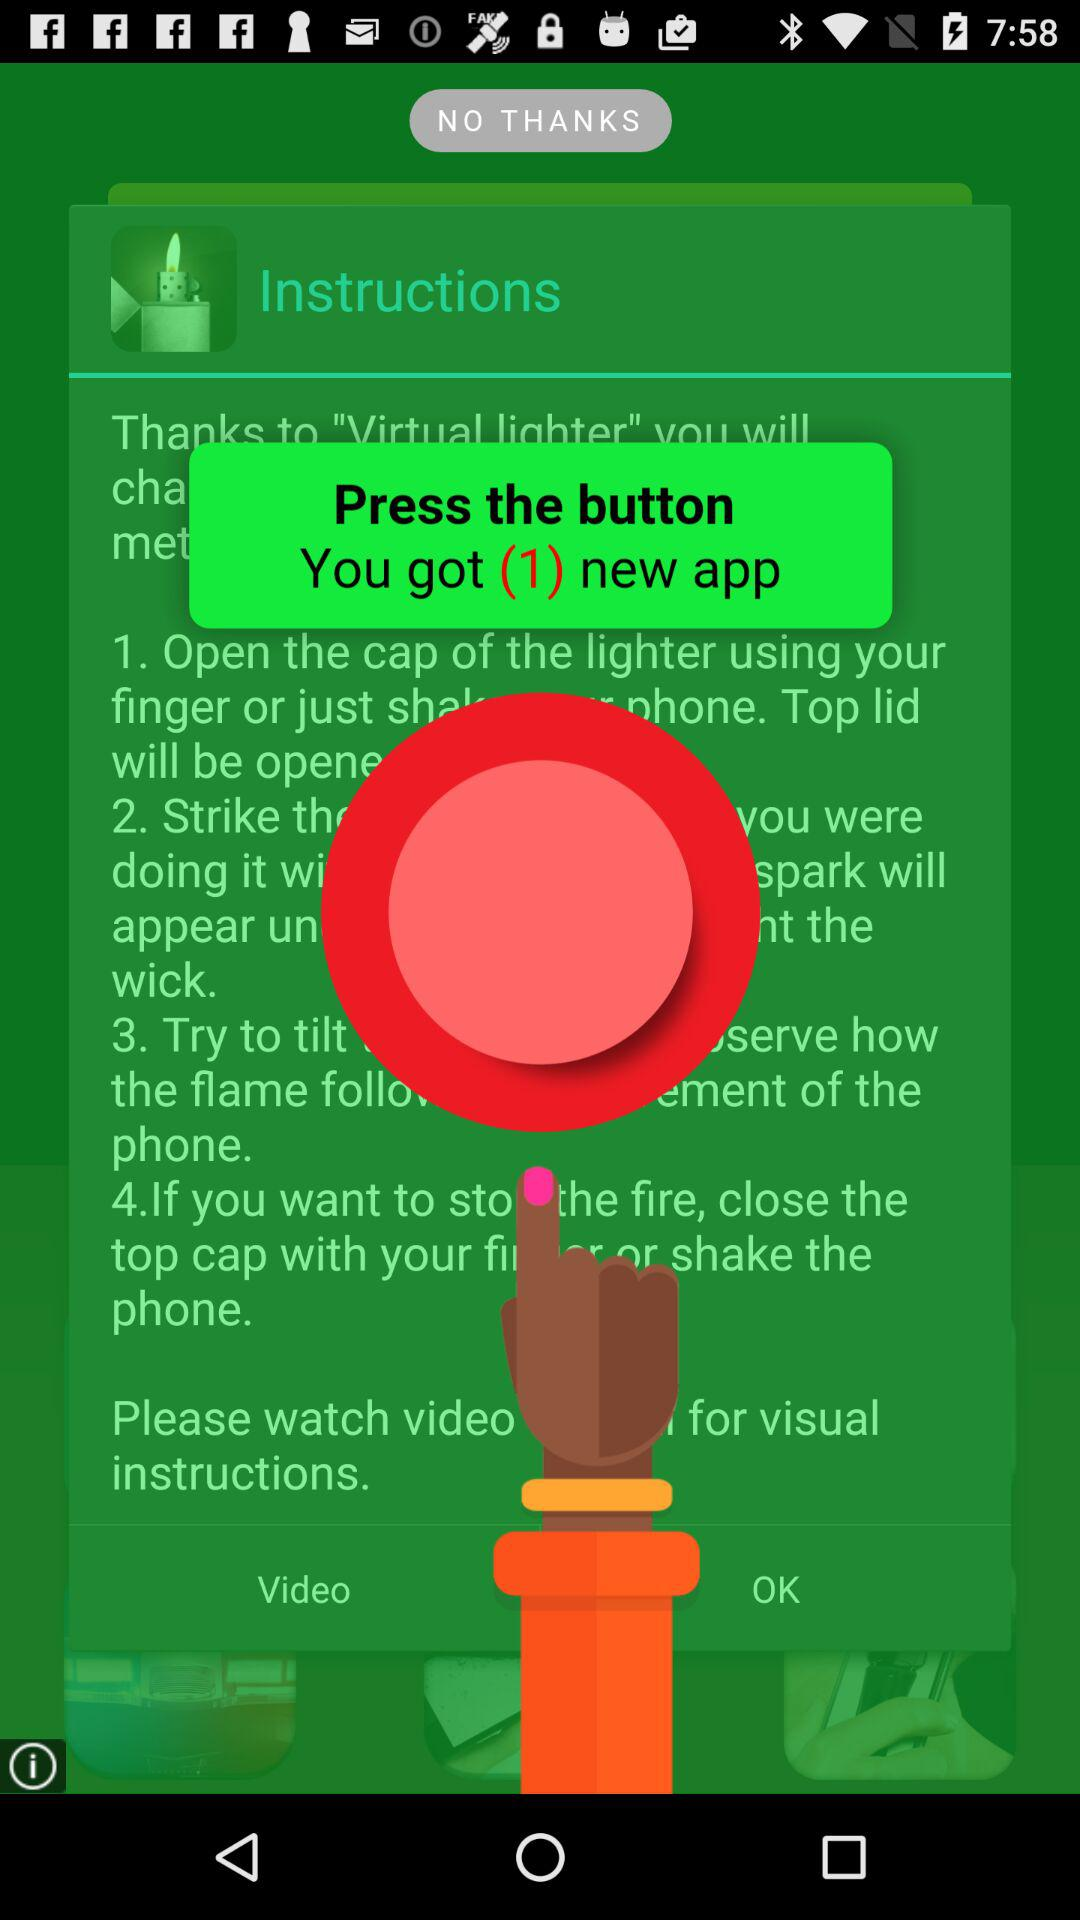How many instructions are there on the screen?
Answer the question using a single word or phrase. 4 